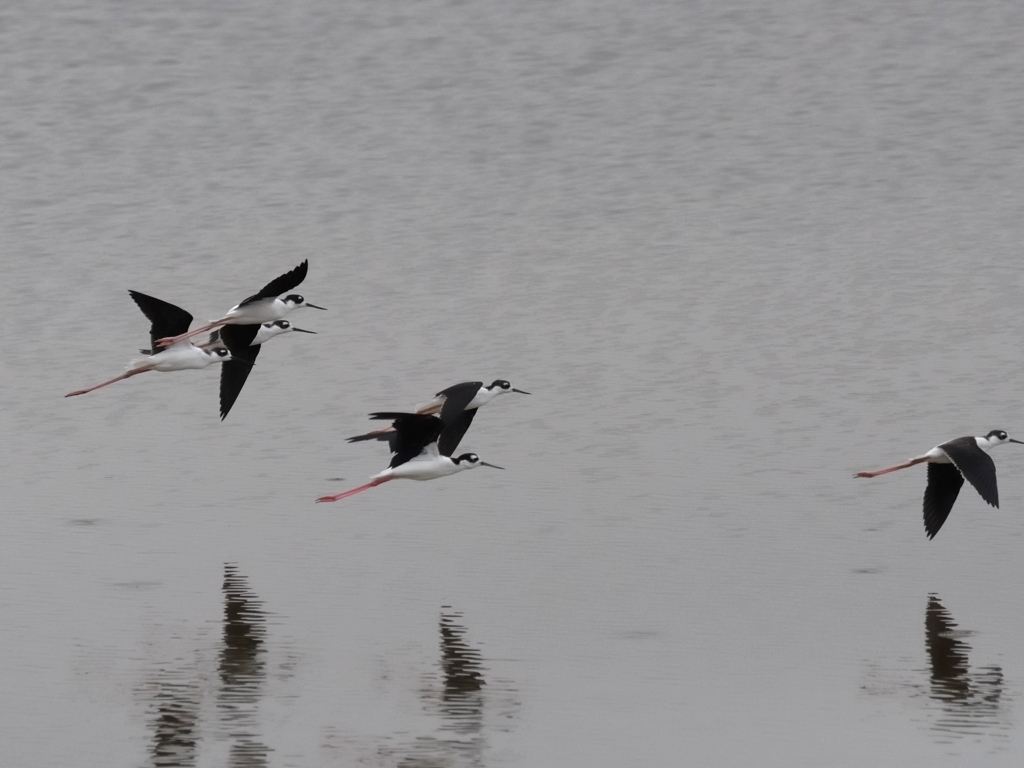How accurate is the focus of this image?
A. Out of focus
B. Blurred
C. Accurate
D. Slightly off
Answer with the option's letter from the given choices directly.
 C. 